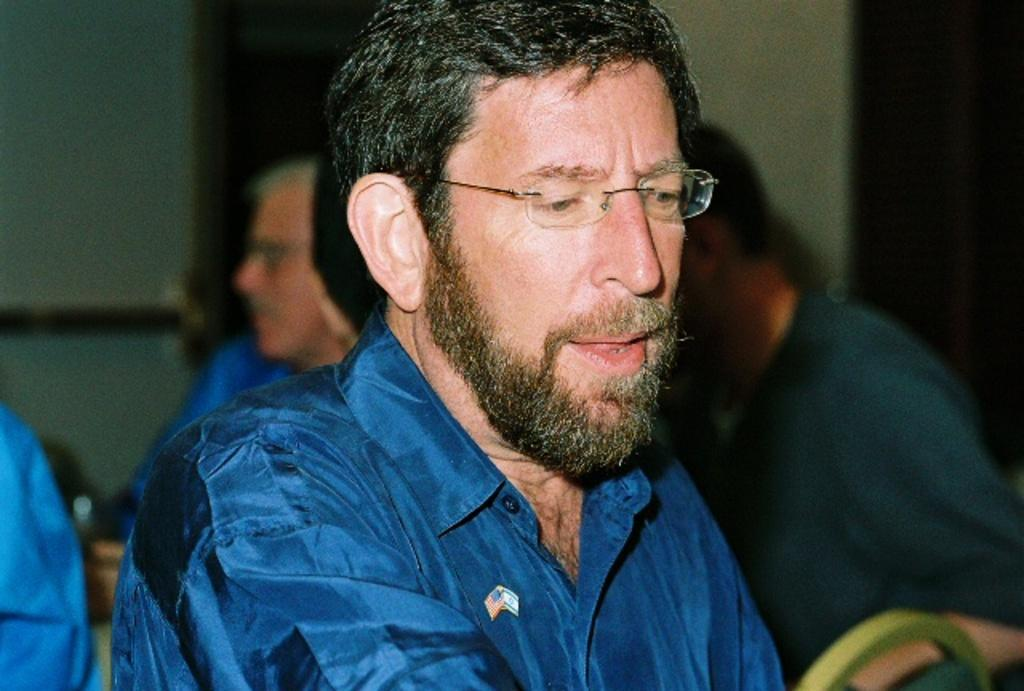Who is present in the image? There is a person in the image. What is the person wearing? The person is wearing a blue dress. Can you describe the background of the image? There are other people in the background of the image, and the wall is cream-colored. How many clocks are hanging on the cream-colored wall in the image? There are no clocks visible on the cream-colored wall in the image. 